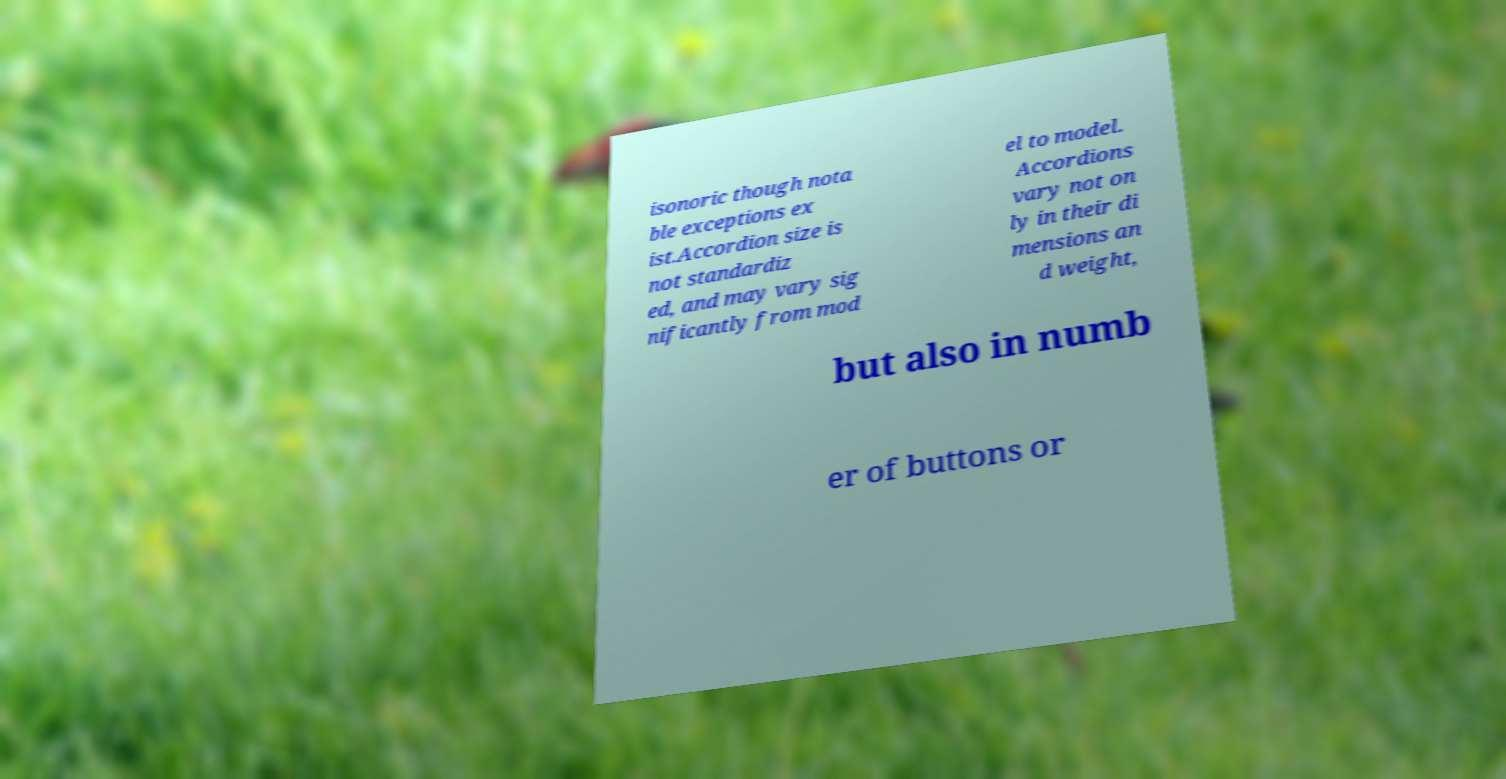Could you extract and type out the text from this image? isonoric though nota ble exceptions ex ist.Accordion size is not standardiz ed, and may vary sig nificantly from mod el to model. Accordions vary not on ly in their di mensions an d weight, but also in numb er of buttons or 